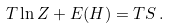Convert formula to latex. <formula><loc_0><loc_0><loc_500><loc_500>T \ln Z + E ( H ) = T S \, .</formula> 